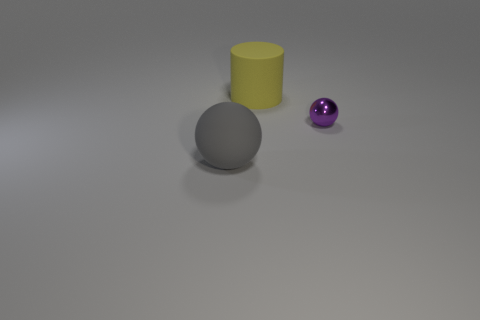Add 3 brown balls. How many objects exist? 6 Subtract all cylinders. How many objects are left? 2 Subtract 1 gray spheres. How many objects are left? 2 Subtract all big brown matte things. Subtract all purple objects. How many objects are left? 2 Add 2 large gray spheres. How many large gray spheres are left? 3 Add 3 yellow balls. How many yellow balls exist? 3 